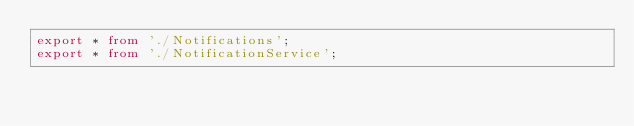<code> <loc_0><loc_0><loc_500><loc_500><_TypeScript_>export * from './Notifications';
export * from './NotificationService';
</code> 